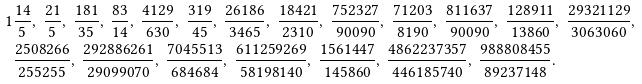<formula> <loc_0><loc_0><loc_500><loc_500>1 & \frac { 1 4 } { 5 } , \ \frac { 2 1 } { 5 } , \ \frac { 1 8 1 } { 3 5 } , \ \frac { 8 3 } { 1 4 } , \ \frac { 4 1 2 9 } { 6 3 0 } , \ \frac { 3 1 9 } { 4 5 } , \ \frac { 2 6 1 8 6 } { 3 4 6 5 } , \ \frac { 1 8 4 2 1 } { 2 3 1 0 } , \ \frac { 7 5 2 3 2 7 } { 9 0 0 9 0 } , \ \frac { 7 1 2 0 3 } { 8 1 9 0 } , \ \frac { 8 1 1 6 3 7 } { 9 0 0 9 0 } , \ \frac { 1 2 8 9 1 1 } { 1 3 8 6 0 } , \ \frac { 2 9 3 2 1 1 2 9 } { 3 0 6 3 0 6 0 } , \\ & \frac { 2 5 0 8 2 6 6 } { 2 5 5 2 5 5 } , \ \frac { 2 9 2 8 8 6 2 6 1 } { 2 9 0 9 9 0 7 0 } , \ \frac { 7 0 4 5 5 1 3 } { 6 8 4 6 8 4 } , \ \frac { 6 1 1 2 5 9 2 6 9 } { 5 8 1 9 8 1 4 0 } , \ \frac { 1 5 6 1 4 4 7 } { 1 4 5 8 6 0 } , \ \frac { 4 8 6 2 2 3 7 3 5 7 } { 4 4 6 1 8 5 7 4 0 } , \ \frac { 9 8 8 8 0 8 4 5 5 } { 8 9 2 3 7 1 4 8 } .</formula> 